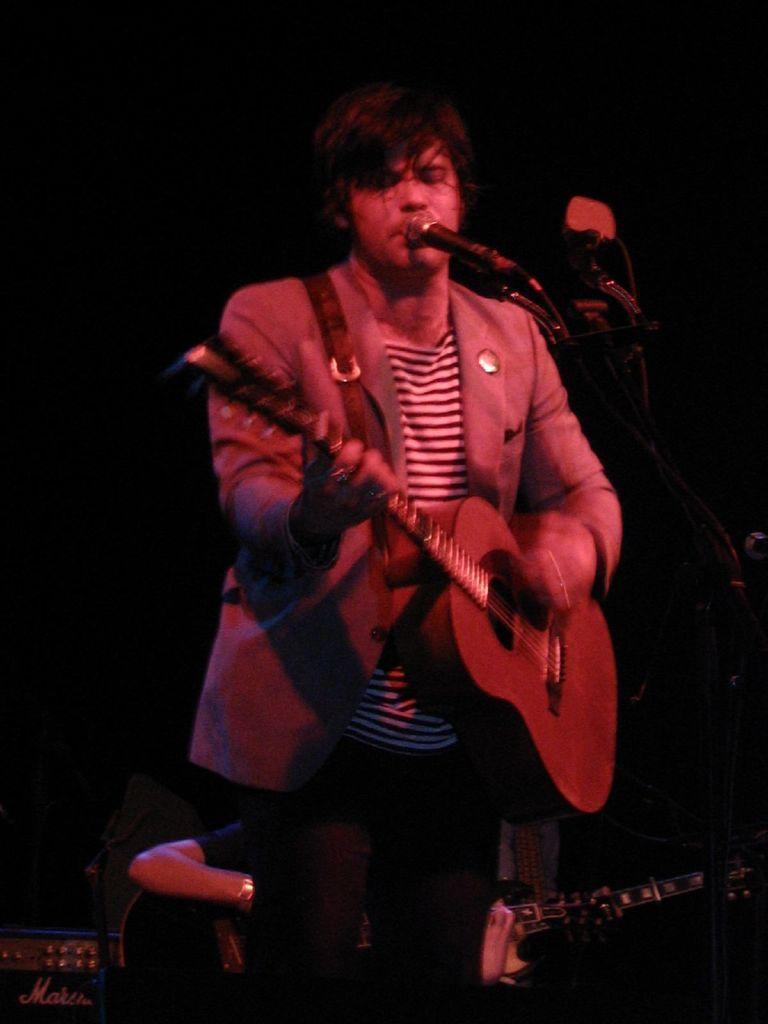Describe this image in one or two sentences. A man with grey is standing and he is playing guitar. In front of him there is a mic. Behind him there is a man playing guitar. 